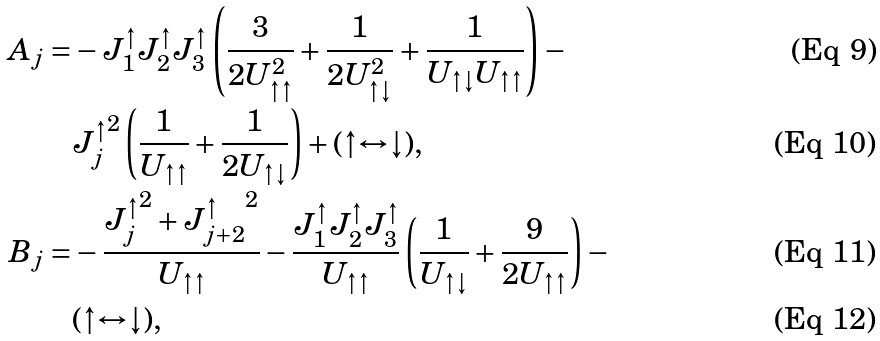<formula> <loc_0><loc_0><loc_500><loc_500>A _ { j } = & - J _ { 1 } ^ { \uparrow } J _ { 2 } ^ { \uparrow } J _ { 3 } ^ { \uparrow } \left ( \frac { 3 } { 2 U _ { \uparrow \uparrow } ^ { 2 } } + \frac { 1 } { 2 U _ { \uparrow \downarrow } ^ { 2 } } + \frac { 1 } { U _ { \uparrow \downarrow } U _ { \uparrow \uparrow } } \right ) - \\ & { J _ { j } ^ { \uparrow } } ^ { 2 } \left ( \frac { 1 } { U _ { \uparrow \uparrow } } + \frac { 1 } { 2 U _ { \uparrow \downarrow } } \right ) + ( \uparrow \leftrightarrow \downarrow ) , \\ B _ { j } = & - \frac { { J _ { j } ^ { \uparrow } } ^ { 2 } + { J _ { j + 2 } ^ { \uparrow } } ^ { 2 } } { U _ { \uparrow \uparrow } } - \frac { J _ { 1 } ^ { \uparrow } J _ { 2 } ^ { \uparrow } J _ { 3 } ^ { \uparrow } } { U _ { \uparrow \uparrow } } \left ( \frac { 1 } { U _ { \uparrow \downarrow } } + \frac { 9 } { 2 U _ { \uparrow \uparrow } } \right ) - \\ & ( \uparrow \leftrightarrow \downarrow ) ,</formula> 